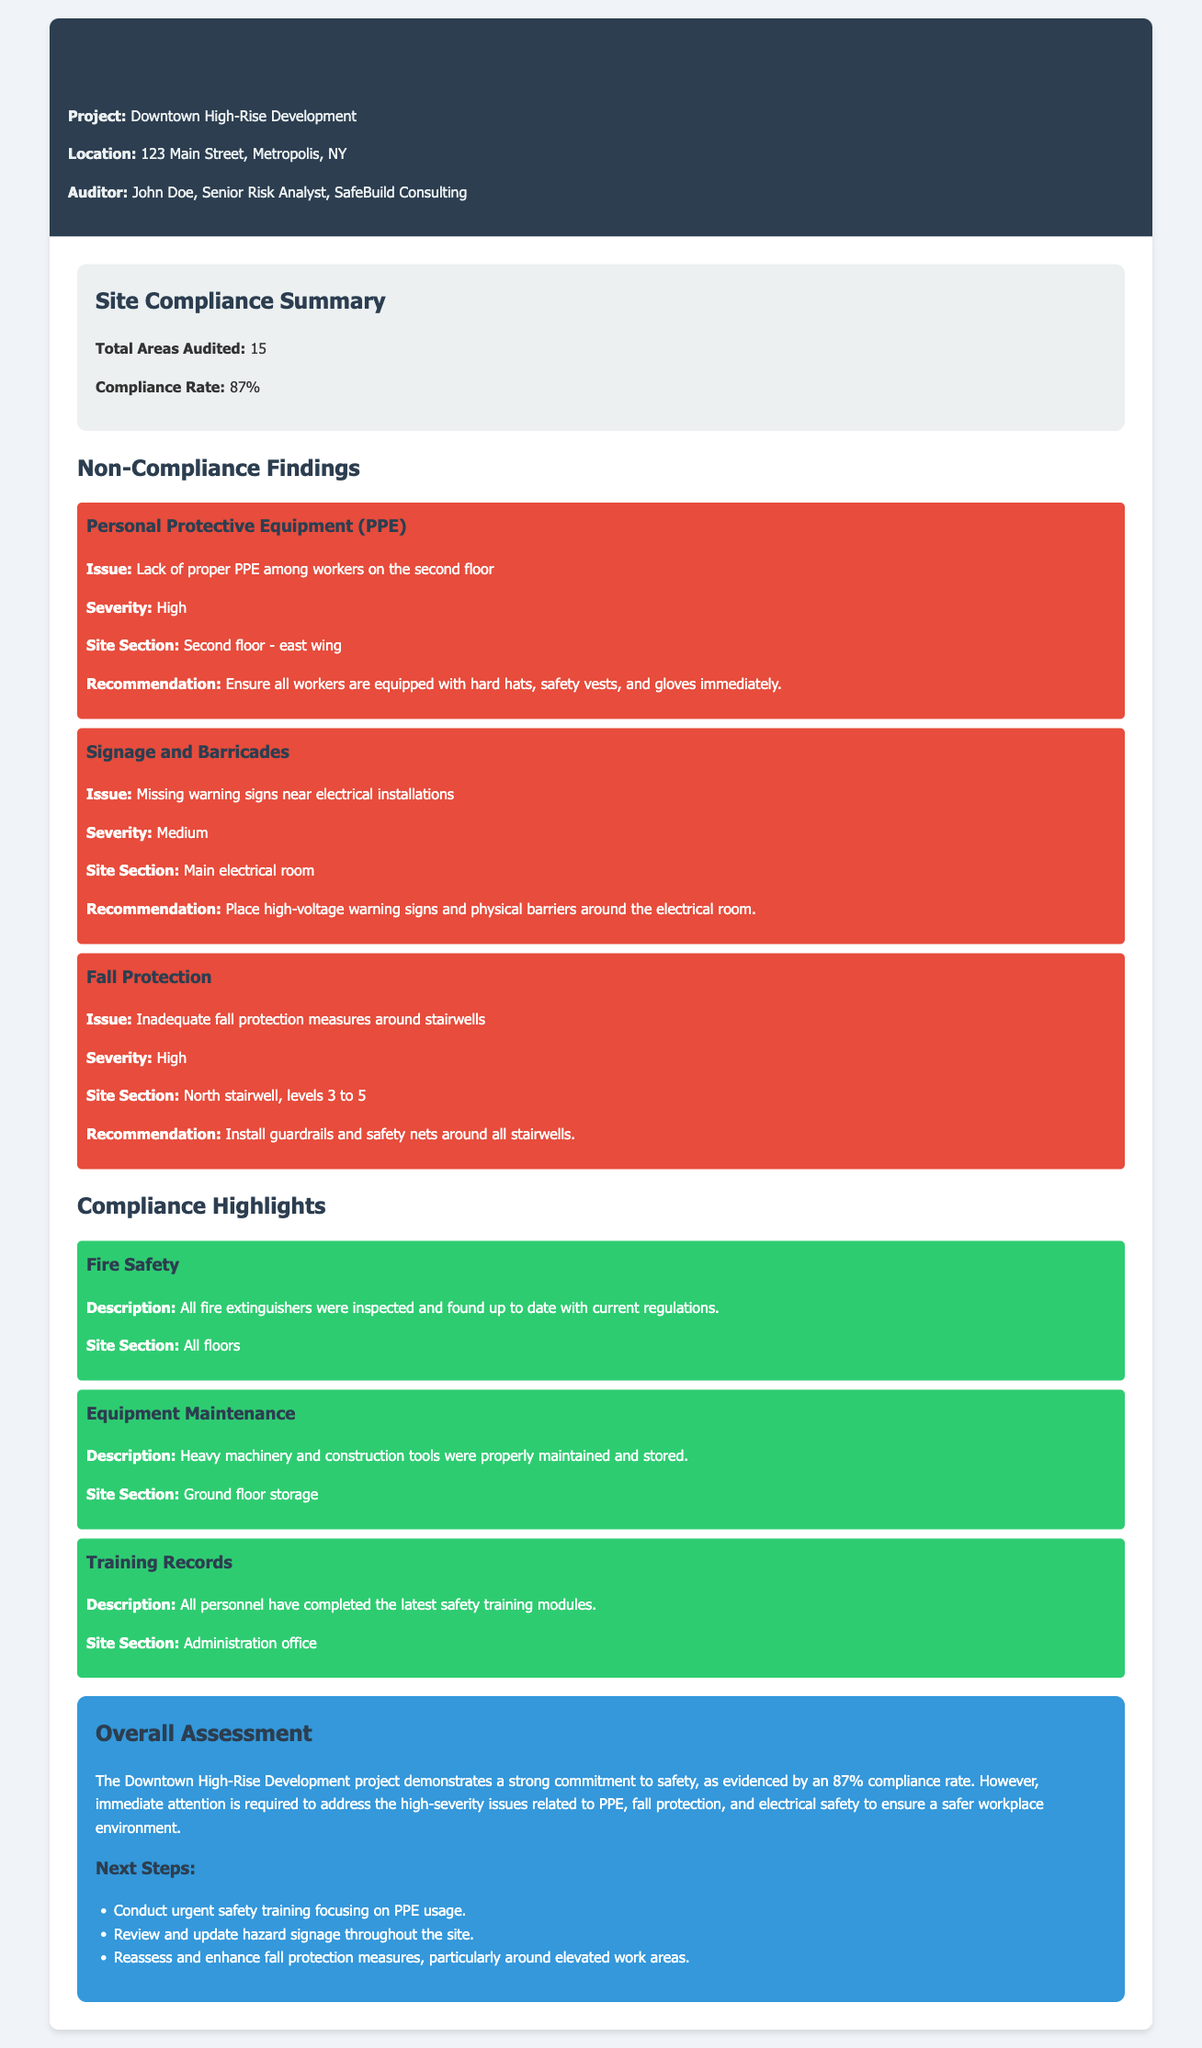what is the compliance rate? The compliance rate is stated in the summary section of the document as a measurement of compliance across audited areas.
Answer: 87% who is the auditor? The auditor's name is mentioned in the header of the document, identifying the individual responsible for the report.
Answer: John Doe what is the total number of areas audited? The total areas audited figure is provided in the summary section, reflecting the scope of the audit conducted.
Answer: 15 what is the issue with Personal Protective Equipment? The specific issue regarding PPE is detailed under non-compliance findings, outlining the problem observed during the audit.
Answer: Lack of proper PPE among workers on the second floor which site section had missing signage? The report specifies the area where the issue of missing signage was found, connecting it to safety protocols.
Answer: Main electrical room what severity level is assigned to fall protection issues? The severity level for the identified issue with fall protection is listed in the non-compliance section, indicating the urgency of the concern.
Answer: High what are the next steps recommended in the assessment? The next steps are outlined at the end of the assessment section and detail actions needed to improve safety protocols.
Answer: Conduct urgent safety training focusing on PPE usage which site section had equipment properly maintained? The document highlights the specific location where equipment maintenance compliance was checked and found satisfactory.
Answer: Ground floor storage what is the description of the fire safety compliance highlight? The compliance highlights section provides details regarding fire safety measures checked during the audit.
Answer: All fire extinguishers were inspected and found up to date with current regulations 